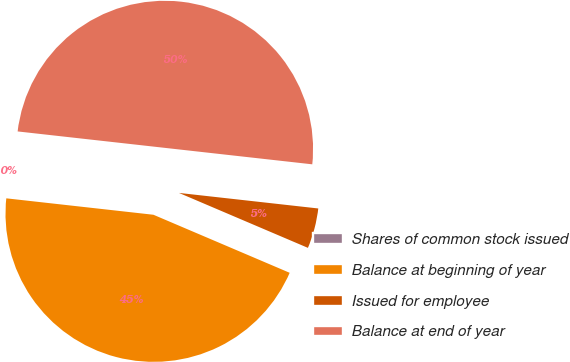<chart> <loc_0><loc_0><loc_500><loc_500><pie_chart><fcel>Shares of common stock issued<fcel>Balance at beginning of year<fcel>Issued for employee<fcel>Balance at end of year<nl><fcel>0.0%<fcel>45.36%<fcel>4.64%<fcel>50.0%<nl></chart> 